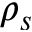<formula> <loc_0><loc_0><loc_500><loc_500>\rho _ { s }</formula> 